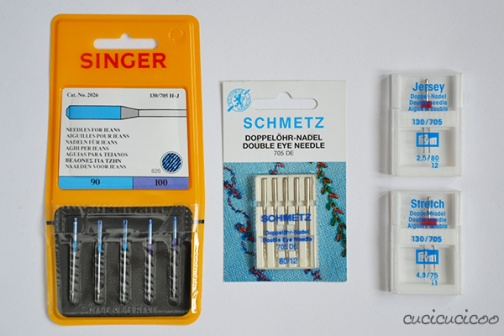What is this photo about'? The image presents a trio of sewing needle packages, each with its own unique characteristics, neatly arranged on a pristine white background. On the left, a vibrant yellow and orange package catches the eye, proudly bearing the Singer brand name. This package contains needles of size 100, specifically designed for knit fabrics.

In the center, a blue and white package stands out with the Schmetz brand name. Unlike the other packages, this one contains double needles, hinting at its capability for more complex sewing tasks.

To the right, a white package of Stretch needles rounds out the trio. It contains needles of sizes 130/705 and 90/14, offering a range of options for different sewing needs.

All three packages are unopened, their contents untouched, suggesting they are fresh from the store and ready to be used. Despite their differences in brand and needle type, they all share a common purpose - to aid in the creation of beautiful sewing projects. 